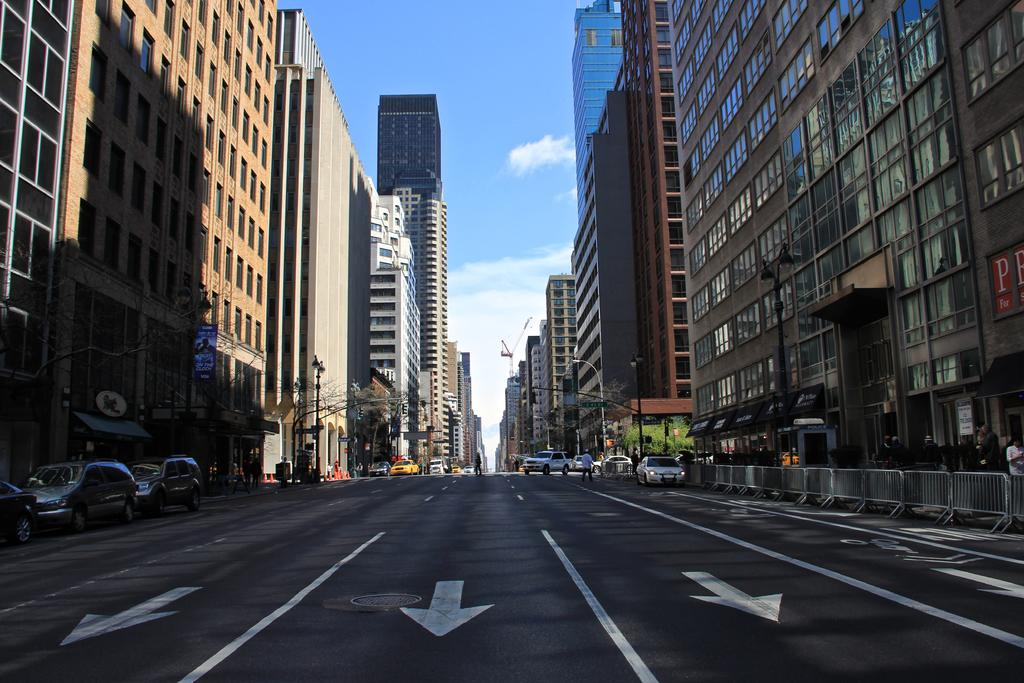What type of structures can be seen in the image? There are buildings in the image. What else can be seen on the ground in the image? Vehicles are present on the road in the image. Are there any living beings visible in the image? Yes, there are people in the image. What other objects can be seen in the image? Poles and trees are present in the image. Is there any barrier or enclosure visible in the image? Yes, there is a fence in the image. What is visible in the background of the image? The sky is visible in the background of the image. What type of glue is being used by the people in the image? There is no glue present in the image, and no indication that the people are using glue. What activity are the people engaging in during their recess in the image? There is no recess depicted in the image, and no indication of any specific activity being performed by the people. 